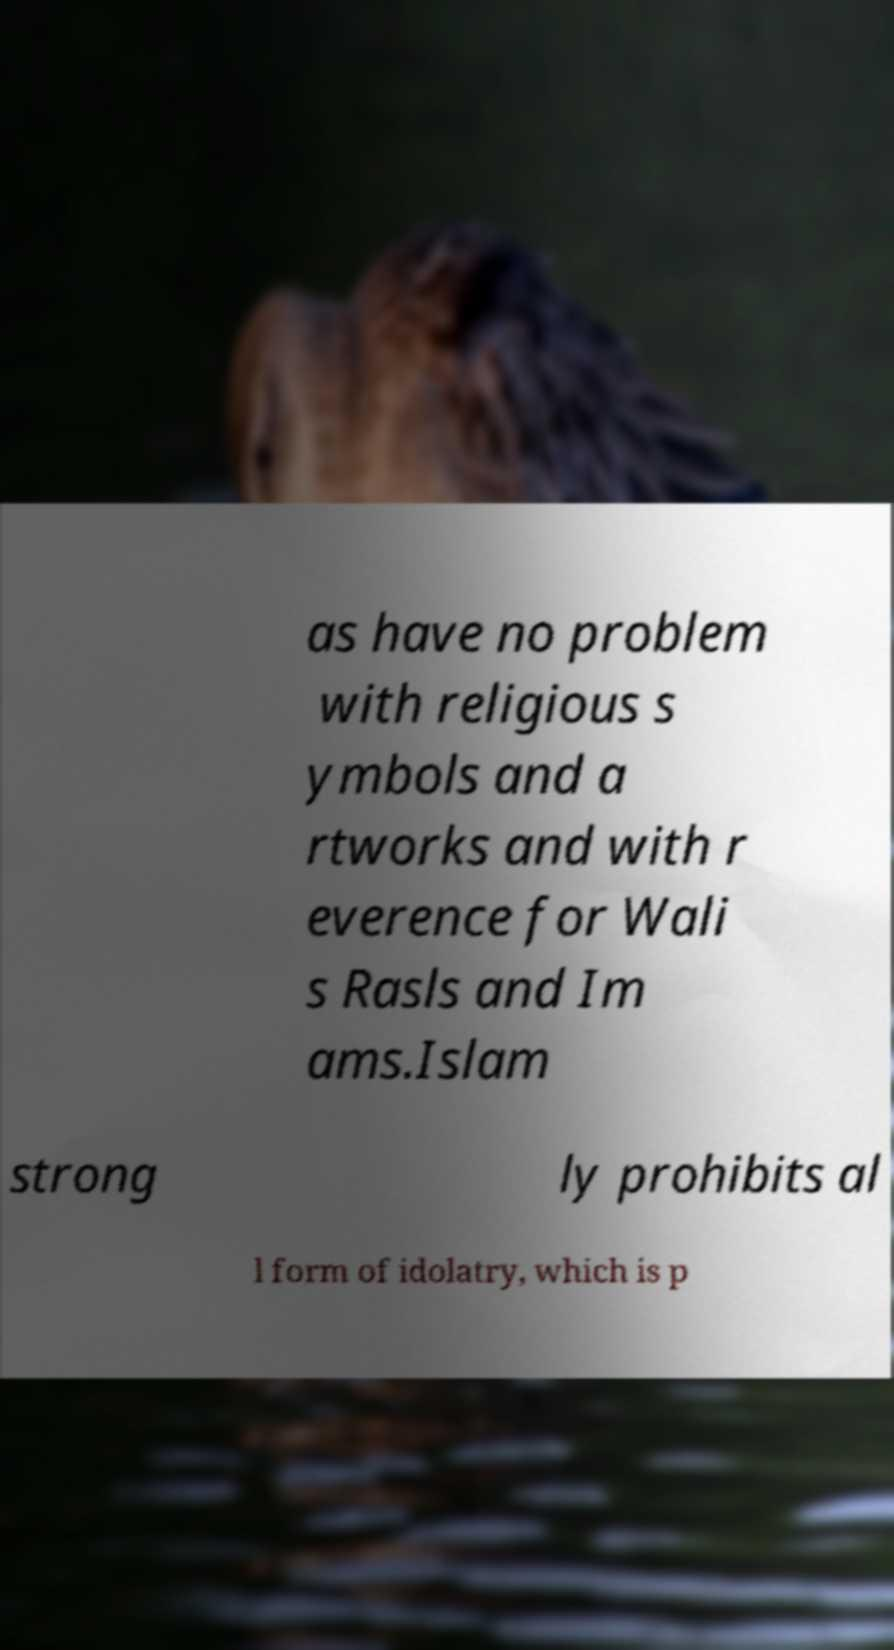Please read and relay the text visible in this image. What does it say? as have no problem with religious s ymbols and a rtworks and with r everence for Wali s Rasls and Im ams.Islam strong ly prohibits al l form of idolatry, which is p 